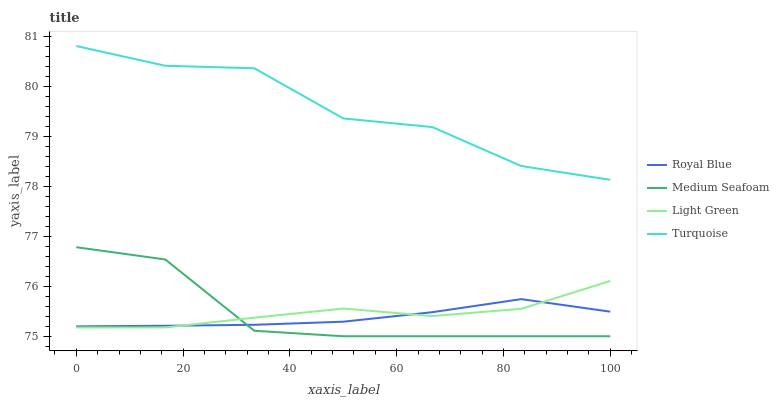Does Royal Blue have the minimum area under the curve?
Answer yes or no. Yes. Does Turquoise have the maximum area under the curve?
Answer yes or no. Yes. Does Medium Seafoam have the minimum area under the curve?
Answer yes or no. No. Does Medium Seafoam have the maximum area under the curve?
Answer yes or no. No. Is Royal Blue the smoothest?
Answer yes or no. Yes. Is Turquoise the roughest?
Answer yes or no. Yes. Is Medium Seafoam the smoothest?
Answer yes or no. No. Is Medium Seafoam the roughest?
Answer yes or no. No. Does Medium Seafoam have the lowest value?
Answer yes or no. Yes. Does Turquoise have the lowest value?
Answer yes or no. No. Does Turquoise have the highest value?
Answer yes or no. Yes. Does Medium Seafoam have the highest value?
Answer yes or no. No. Is Light Green less than Turquoise?
Answer yes or no. Yes. Is Turquoise greater than Royal Blue?
Answer yes or no. Yes. Does Royal Blue intersect Light Green?
Answer yes or no. Yes. Is Royal Blue less than Light Green?
Answer yes or no. No. Is Royal Blue greater than Light Green?
Answer yes or no. No. Does Light Green intersect Turquoise?
Answer yes or no. No. 